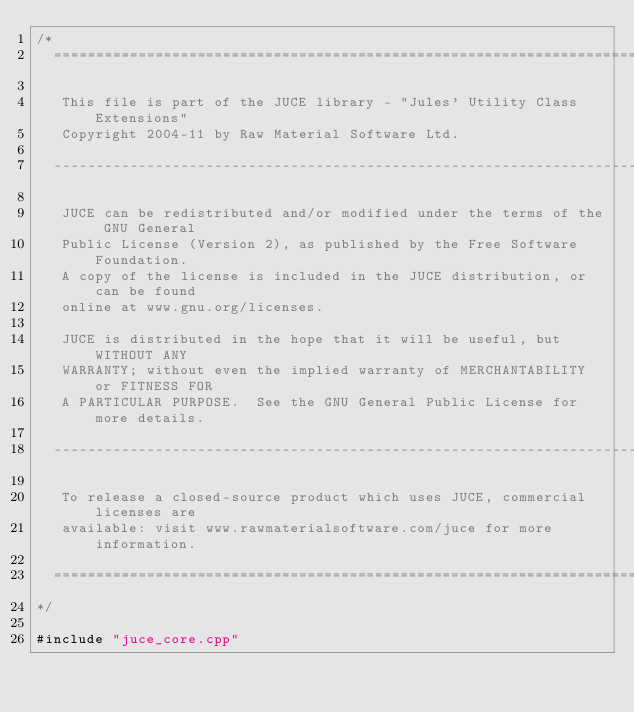Convert code to text. <code><loc_0><loc_0><loc_500><loc_500><_ObjectiveC_>/*
  ==============================================================================

   This file is part of the JUCE library - "Jules' Utility Class Extensions"
   Copyright 2004-11 by Raw Material Software Ltd.

  ------------------------------------------------------------------------------

   JUCE can be redistributed and/or modified under the terms of the GNU General
   Public License (Version 2), as published by the Free Software Foundation.
   A copy of the license is included in the JUCE distribution, or can be found
   online at www.gnu.org/licenses.

   JUCE is distributed in the hope that it will be useful, but WITHOUT ANY
   WARRANTY; without even the implied warranty of MERCHANTABILITY or FITNESS FOR
   A PARTICULAR PURPOSE.  See the GNU General Public License for more details.

  ------------------------------------------------------------------------------

   To release a closed-source product which uses JUCE, commercial licenses are
   available: visit www.rawmaterialsoftware.com/juce for more information.

  ==============================================================================
*/

#include "juce_core.cpp"
</code> 